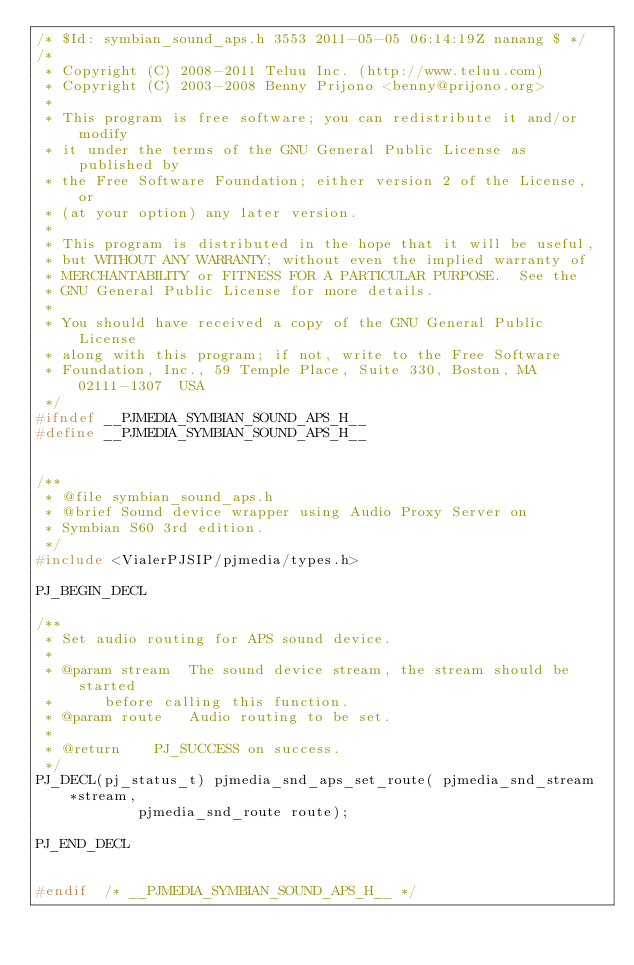<code> <loc_0><loc_0><loc_500><loc_500><_C_>/* $Id: symbian_sound_aps.h 3553 2011-05-05 06:14:19Z nanang $ */
/* 
 * Copyright (C) 2008-2011 Teluu Inc. (http://www.teluu.com)
 * Copyright (C) 2003-2008 Benny Prijono <benny@prijono.org>
 *
 * This program is free software; you can redistribute it and/or modify
 * it under the terms of the GNU General Public License as published by
 * the Free Software Foundation; either version 2 of the License, or
 * (at your option) any later version.
 *
 * This program is distributed in the hope that it will be useful,
 * but WITHOUT ANY WARRANTY; without even the implied warranty of
 * MERCHANTABILITY or FITNESS FOR A PARTICULAR PURPOSE.  See the
 * GNU General Public License for more details.
 *
 * You should have received a copy of the GNU General Public License
 * along with this program; if not, write to the Free Software
 * Foundation, Inc., 59 Temple Place, Suite 330, Boston, MA  02111-1307  USA 
 */
#ifndef __PJMEDIA_SYMBIAN_SOUND_APS_H__
#define __PJMEDIA_SYMBIAN_SOUND_APS_H__


/**
 * @file symbian_sound_aps.h
 * @brief Sound device wrapper using Audio Proxy Server on 
 * Symbian S60 3rd edition.
 */
#include <VialerPJSIP/pjmedia/types.h>

PJ_BEGIN_DECL

/**
 * Set audio routing for APS sound device.
 *
 * @param stream	The sound device stream, the stream should be started 
 *			before calling this function.
 * @param route		Audio routing to be set.
 *
 * @return		PJ_SUCCESS on success.
 */
PJ_DECL(pj_status_t) pjmedia_snd_aps_set_route( pjmedia_snd_stream *stream,
						pjmedia_snd_route route);

PJ_END_DECL


#endif	/* __PJMEDIA_SYMBIAN_SOUND_APS_H__ */
</code> 